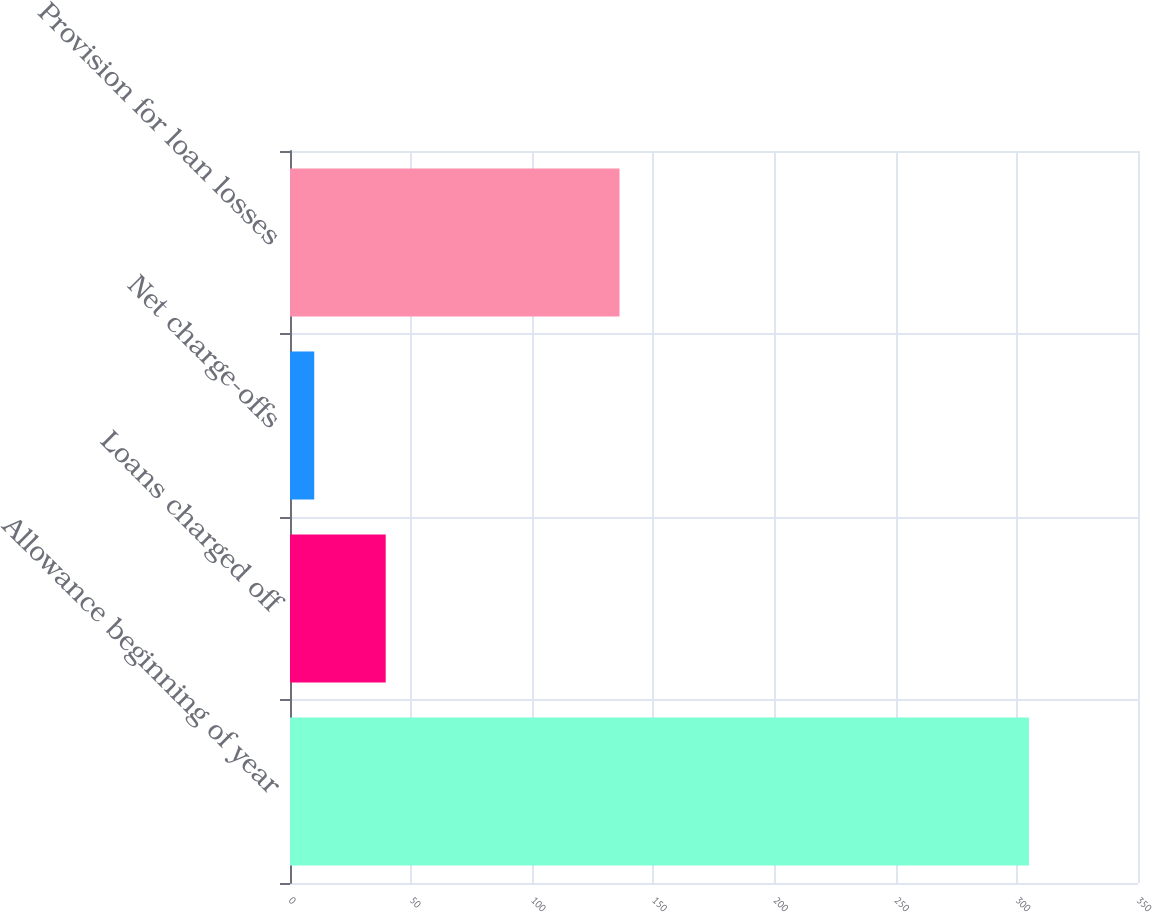<chart> <loc_0><loc_0><loc_500><loc_500><bar_chart><fcel>Allowance beginning of year<fcel>Loans charged off<fcel>Net charge-offs<fcel>Provision for loan losses<nl><fcel>305<fcel>39.5<fcel>10<fcel>136<nl></chart> 